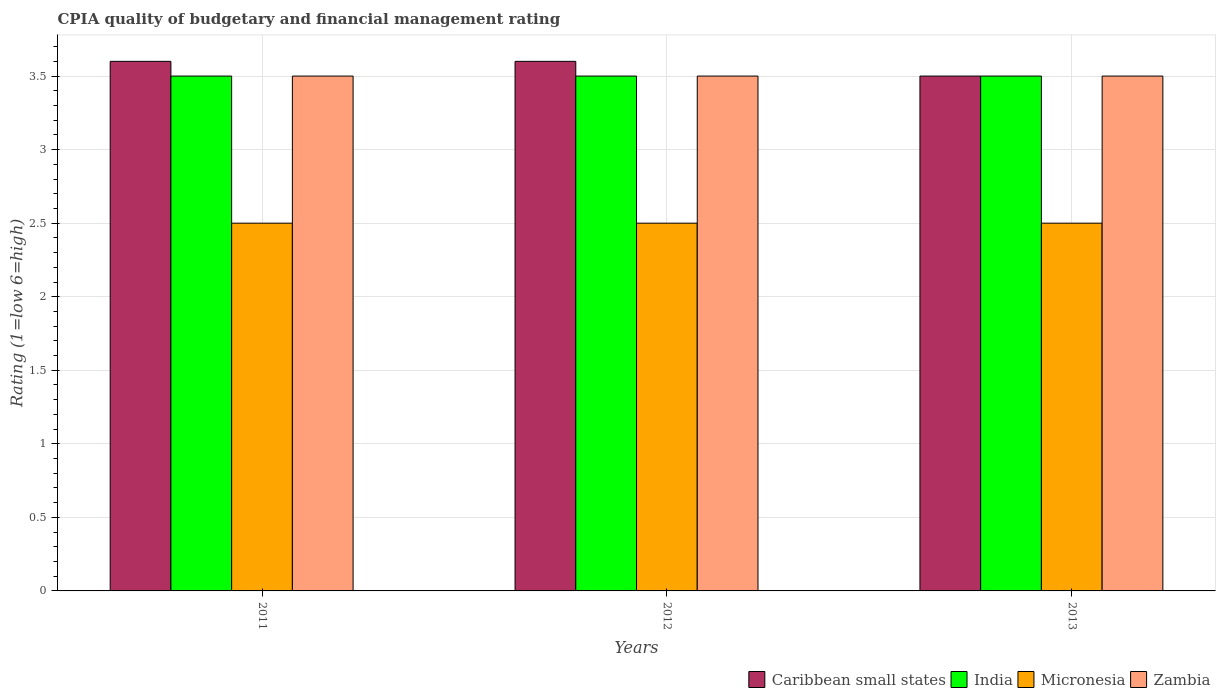How many different coloured bars are there?
Your response must be concise. 4. How many groups of bars are there?
Ensure brevity in your answer.  3. Are the number of bars per tick equal to the number of legend labels?
Provide a succinct answer. Yes. In how many cases, is the number of bars for a given year not equal to the number of legend labels?
Keep it short and to the point. 0. Across all years, what is the minimum CPIA rating in India?
Keep it short and to the point. 3.5. In which year was the CPIA rating in Caribbean small states maximum?
Your answer should be compact. 2011. In which year was the CPIA rating in Micronesia minimum?
Offer a very short reply. 2011. What is the difference between the CPIA rating in Micronesia in 2011 and that in 2012?
Keep it short and to the point. 0. What is the average CPIA rating in Micronesia per year?
Offer a very short reply. 2.5. In the year 2011, what is the difference between the CPIA rating in India and CPIA rating in Micronesia?
Keep it short and to the point. 1. In how many years, is the CPIA rating in Micronesia greater than 0.8?
Offer a very short reply. 3. Is the CPIA rating in Zambia in 2011 less than that in 2012?
Offer a very short reply. No. Is the difference between the CPIA rating in India in 2011 and 2013 greater than the difference between the CPIA rating in Micronesia in 2011 and 2013?
Provide a succinct answer. No. In how many years, is the CPIA rating in Zambia greater than the average CPIA rating in Zambia taken over all years?
Your response must be concise. 0. Is the sum of the CPIA rating in India in 2011 and 2013 greater than the maximum CPIA rating in Micronesia across all years?
Your answer should be very brief. Yes. Is it the case that in every year, the sum of the CPIA rating in Micronesia and CPIA rating in Zambia is greater than the sum of CPIA rating in Caribbean small states and CPIA rating in India?
Give a very brief answer. Yes. What does the 4th bar from the left in 2012 represents?
Provide a short and direct response. Zambia. What does the 2nd bar from the right in 2012 represents?
Keep it short and to the point. Micronesia. Is it the case that in every year, the sum of the CPIA rating in Micronesia and CPIA rating in India is greater than the CPIA rating in Zambia?
Offer a very short reply. Yes. How many years are there in the graph?
Ensure brevity in your answer.  3. Are the values on the major ticks of Y-axis written in scientific E-notation?
Provide a short and direct response. No. Does the graph contain any zero values?
Your answer should be compact. No. Where does the legend appear in the graph?
Ensure brevity in your answer.  Bottom right. How are the legend labels stacked?
Keep it short and to the point. Horizontal. What is the title of the graph?
Ensure brevity in your answer.  CPIA quality of budgetary and financial management rating. What is the label or title of the Y-axis?
Provide a short and direct response. Rating (1=low 6=high). What is the Rating (1=low 6=high) of Caribbean small states in 2011?
Your response must be concise. 3.6. What is the Rating (1=low 6=high) of India in 2011?
Your response must be concise. 3.5. What is the Rating (1=low 6=high) of Zambia in 2011?
Your response must be concise. 3.5. What is the Rating (1=low 6=high) in India in 2012?
Provide a succinct answer. 3.5. What is the Rating (1=low 6=high) of Micronesia in 2012?
Make the answer very short. 2.5. What is the Rating (1=low 6=high) of Micronesia in 2013?
Offer a very short reply. 2.5. Across all years, what is the maximum Rating (1=low 6=high) of Caribbean small states?
Give a very brief answer. 3.6. Across all years, what is the minimum Rating (1=low 6=high) in Caribbean small states?
Ensure brevity in your answer.  3.5. Across all years, what is the minimum Rating (1=low 6=high) of Zambia?
Provide a succinct answer. 3.5. What is the total Rating (1=low 6=high) of Caribbean small states in the graph?
Provide a succinct answer. 10.7. What is the total Rating (1=low 6=high) in Micronesia in the graph?
Your answer should be very brief. 7.5. What is the total Rating (1=low 6=high) in Zambia in the graph?
Make the answer very short. 10.5. What is the difference between the Rating (1=low 6=high) of India in 2011 and that in 2012?
Your answer should be compact. 0. What is the difference between the Rating (1=low 6=high) of Zambia in 2011 and that in 2012?
Your answer should be compact. 0. What is the difference between the Rating (1=low 6=high) of Caribbean small states in 2011 and that in 2013?
Offer a very short reply. 0.1. What is the difference between the Rating (1=low 6=high) in India in 2011 and that in 2013?
Provide a succinct answer. 0. What is the difference between the Rating (1=low 6=high) in Micronesia in 2011 and that in 2013?
Offer a terse response. 0. What is the difference between the Rating (1=low 6=high) of Caribbean small states in 2012 and that in 2013?
Your response must be concise. 0.1. What is the difference between the Rating (1=low 6=high) in India in 2012 and that in 2013?
Provide a succinct answer. 0. What is the difference between the Rating (1=low 6=high) in Zambia in 2012 and that in 2013?
Your response must be concise. 0. What is the difference between the Rating (1=low 6=high) in India in 2011 and the Rating (1=low 6=high) in Zambia in 2012?
Give a very brief answer. 0. What is the difference between the Rating (1=low 6=high) in Caribbean small states in 2011 and the Rating (1=low 6=high) in Micronesia in 2013?
Provide a short and direct response. 1.1. What is the difference between the Rating (1=low 6=high) of Caribbean small states in 2011 and the Rating (1=low 6=high) of Zambia in 2013?
Your answer should be compact. 0.1. What is the difference between the Rating (1=low 6=high) in India in 2011 and the Rating (1=low 6=high) in Micronesia in 2013?
Make the answer very short. 1. What is the difference between the Rating (1=low 6=high) in India in 2011 and the Rating (1=low 6=high) in Zambia in 2013?
Offer a very short reply. 0. What is the difference between the Rating (1=low 6=high) of Caribbean small states in 2012 and the Rating (1=low 6=high) of Micronesia in 2013?
Make the answer very short. 1.1. What is the difference between the Rating (1=low 6=high) in Caribbean small states in 2012 and the Rating (1=low 6=high) in Zambia in 2013?
Provide a succinct answer. 0.1. What is the difference between the Rating (1=low 6=high) of India in 2012 and the Rating (1=low 6=high) of Micronesia in 2013?
Keep it short and to the point. 1. What is the difference between the Rating (1=low 6=high) of Micronesia in 2012 and the Rating (1=low 6=high) of Zambia in 2013?
Your response must be concise. -1. What is the average Rating (1=low 6=high) in Caribbean small states per year?
Provide a short and direct response. 3.57. In the year 2011, what is the difference between the Rating (1=low 6=high) of Caribbean small states and Rating (1=low 6=high) of Micronesia?
Offer a very short reply. 1.1. In the year 2011, what is the difference between the Rating (1=low 6=high) of Caribbean small states and Rating (1=low 6=high) of Zambia?
Your answer should be very brief. 0.1. In the year 2011, what is the difference between the Rating (1=low 6=high) of India and Rating (1=low 6=high) of Zambia?
Your response must be concise. 0. In the year 2012, what is the difference between the Rating (1=low 6=high) in Caribbean small states and Rating (1=low 6=high) in India?
Provide a short and direct response. 0.1. In the year 2012, what is the difference between the Rating (1=low 6=high) of India and Rating (1=low 6=high) of Zambia?
Offer a terse response. 0. In the year 2012, what is the difference between the Rating (1=low 6=high) in Micronesia and Rating (1=low 6=high) in Zambia?
Offer a terse response. -1. In the year 2013, what is the difference between the Rating (1=low 6=high) in Caribbean small states and Rating (1=low 6=high) in India?
Your answer should be compact. 0. In the year 2013, what is the difference between the Rating (1=low 6=high) in Caribbean small states and Rating (1=low 6=high) in Zambia?
Ensure brevity in your answer.  0. In the year 2013, what is the difference between the Rating (1=low 6=high) of India and Rating (1=low 6=high) of Zambia?
Your answer should be compact. 0. In the year 2013, what is the difference between the Rating (1=low 6=high) of Micronesia and Rating (1=low 6=high) of Zambia?
Your answer should be compact. -1. What is the ratio of the Rating (1=low 6=high) of Micronesia in 2011 to that in 2012?
Provide a succinct answer. 1. What is the ratio of the Rating (1=low 6=high) in Zambia in 2011 to that in 2012?
Ensure brevity in your answer.  1. What is the ratio of the Rating (1=low 6=high) of Caribbean small states in 2011 to that in 2013?
Ensure brevity in your answer.  1.03. What is the ratio of the Rating (1=low 6=high) of India in 2011 to that in 2013?
Your response must be concise. 1. What is the ratio of the Rating (1=low 6=high) of Caribbean small states in 2012 to that in 2013?
Your answer should be compact. 1.03. What is the ratio of the Rating (1=low 6=high) in India in 2012 to that in 2013?
Your answer should be compact. 1. What is the ratio of the Rating (1=low 6=high) of Micronesia in 2012 to that in 2013?
Keep it short and to the point. 1. What is the ratio of the Rating (1=low 6=high) in Zambia in 2012 to that in 2013?
Give a very brief answer. 1. What is the difference between the highest and the second highest Rating (1=low 6=high) in Caribbean small states?
Your answer should be very brief. 0. What is the difference between the highest and the second highest Rating (1=low 6=high) of Micronesia?
Offer a terse response. 0. What is the difference between the highest and the lowest Rating (1=low 6=high) in India?
Give a very brief answer. 0. 